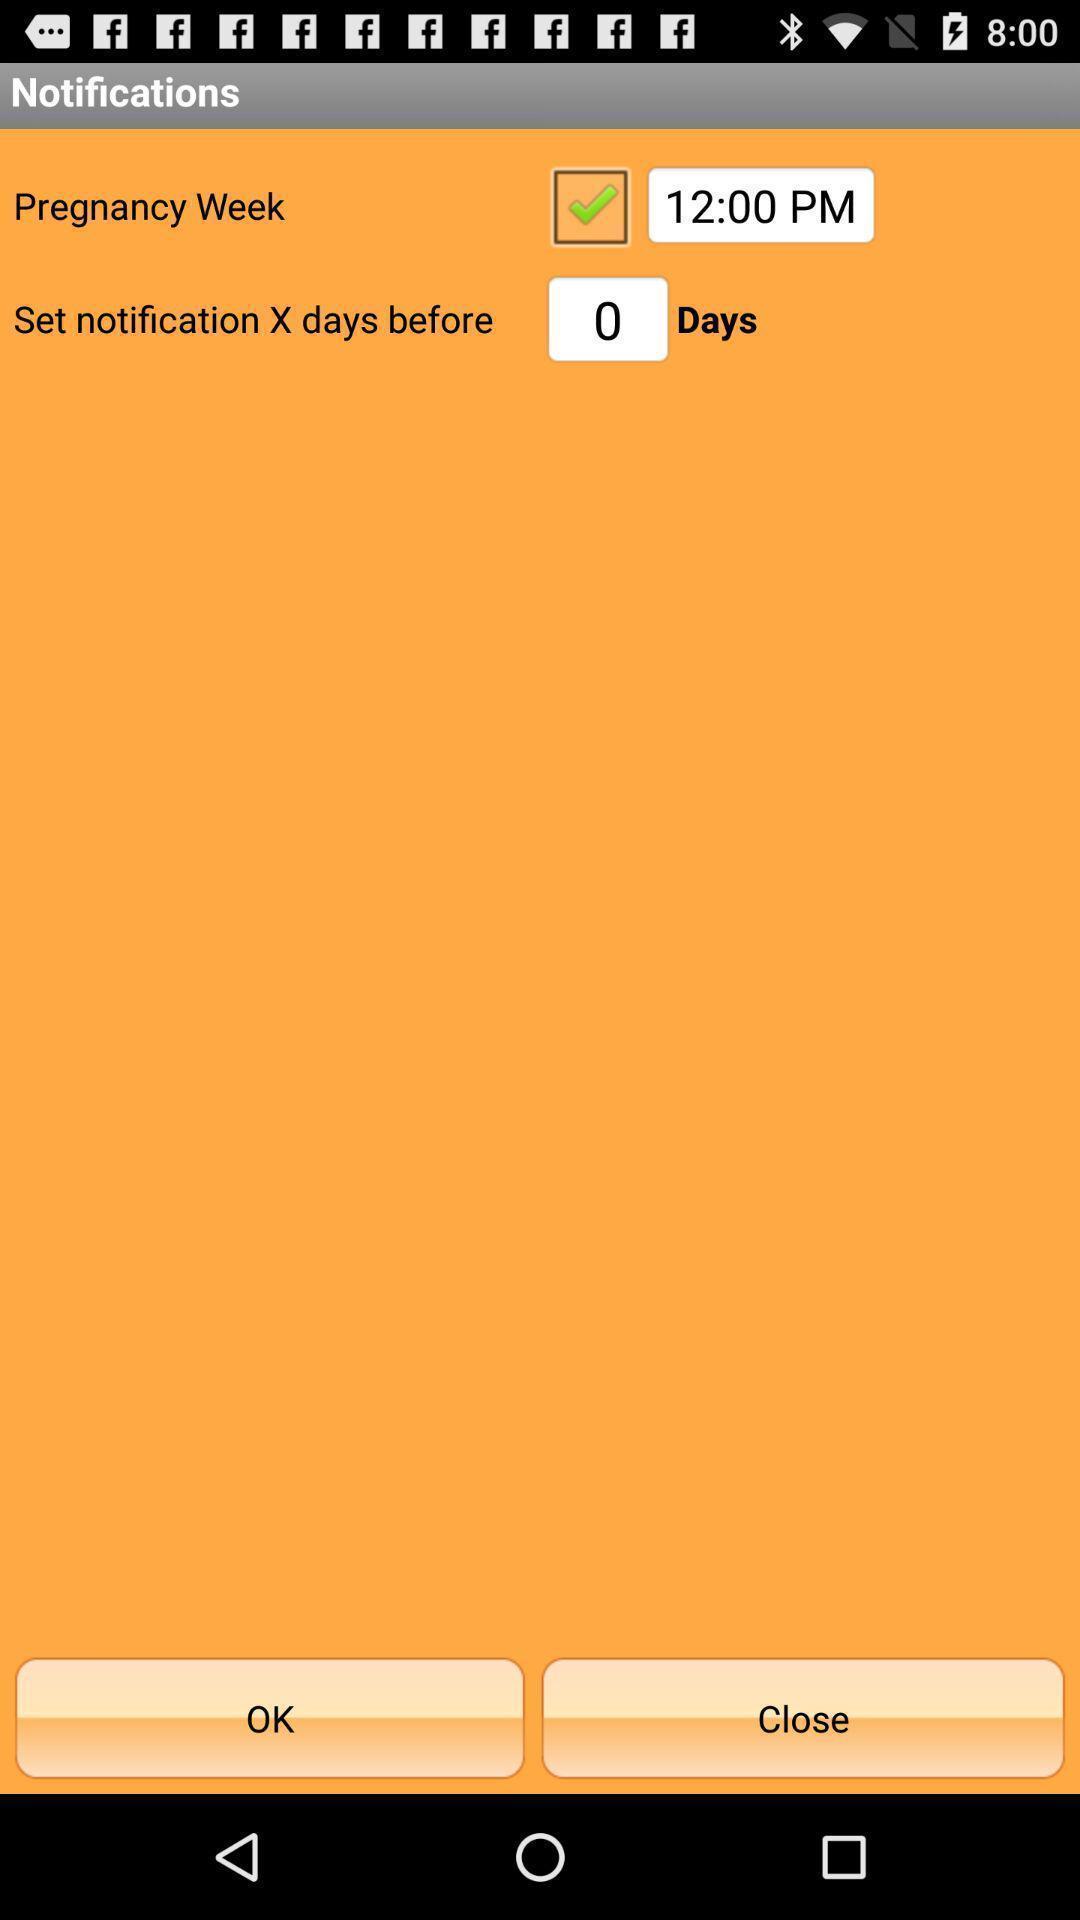Explain what's happening in this screen capture. Page showing notifications setting of the app. 